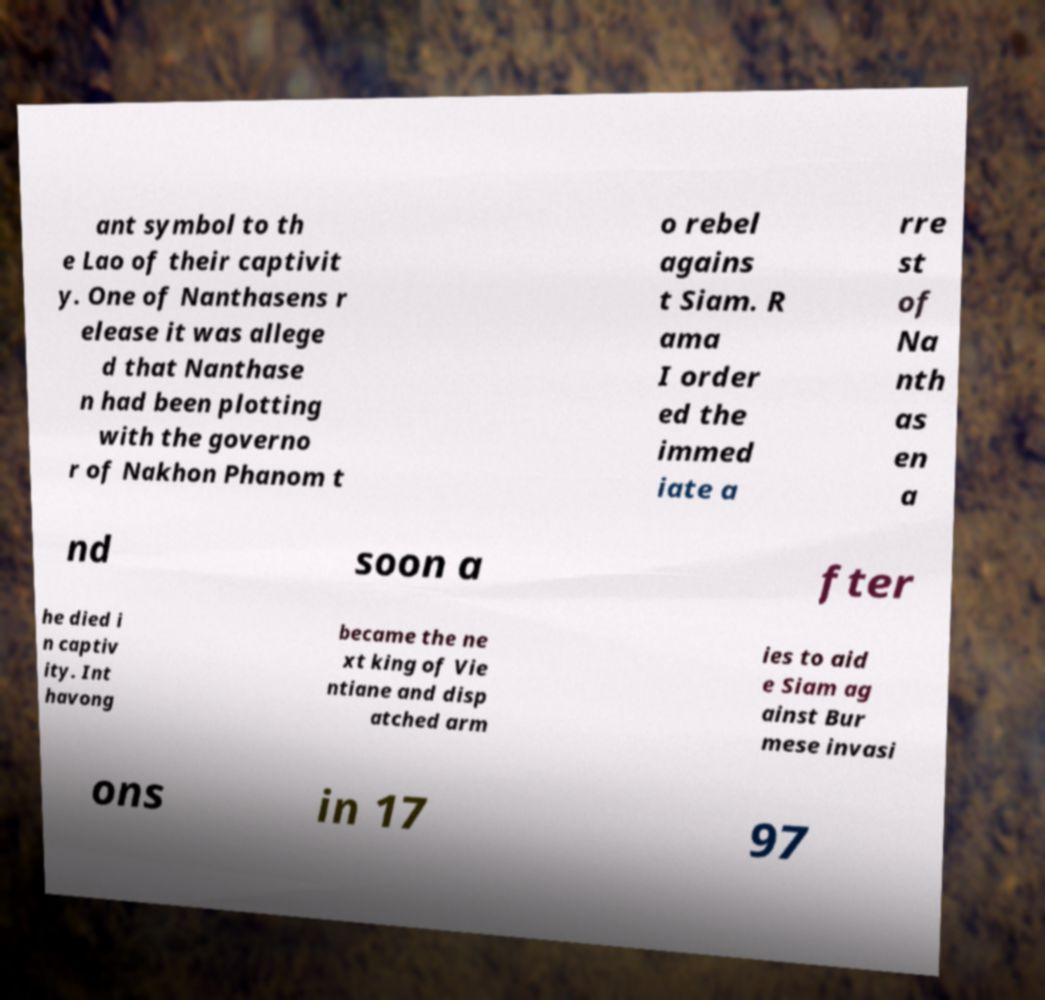Please identify and transcribe the text found in this image. ant symbol to th e Lao of their captivit y. One of Nanthasens r elease it was allege d that Nanthase n had been plotting with the governo r of Nakhon Phanom t o rebel agains t Siam. R ama I order ed the immed iate a rre st of Na nth as en a nd soon a fter he died i n captiv ity. Int havong became the ne xt king of Vie ntiane and disp atched arm ies to aid e Siam ag ainst Bur mese invasi ons in 17 97 